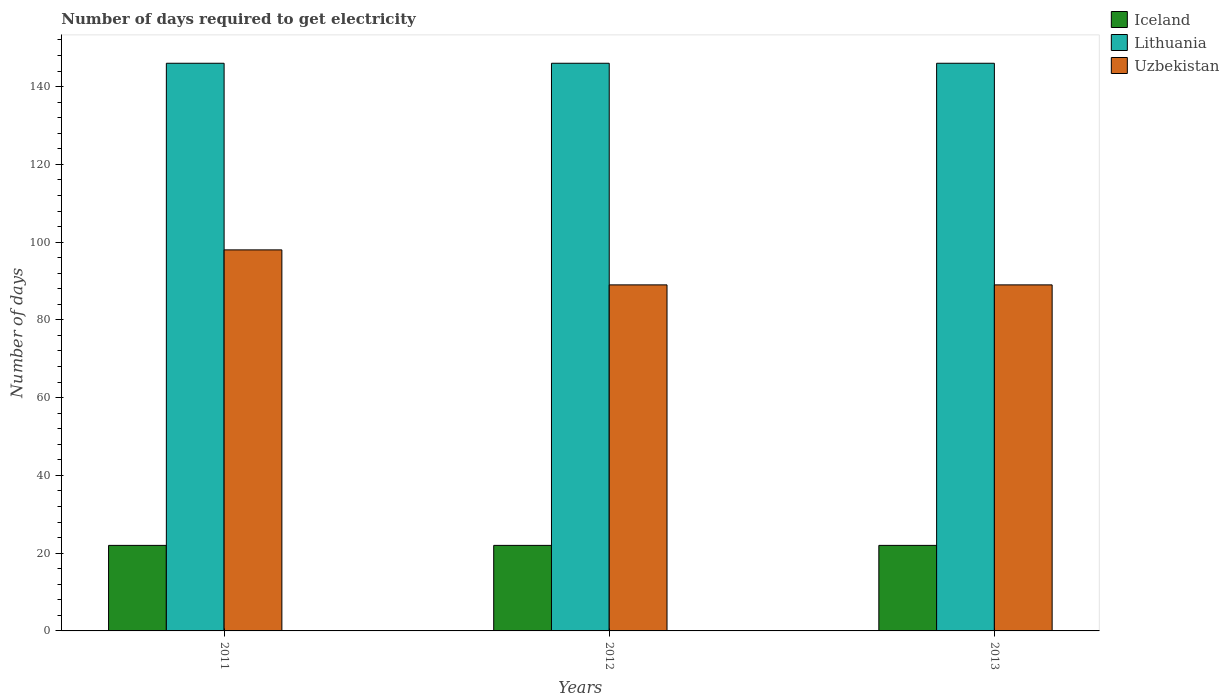How many bars are there on the 3rd tick from the right?
Your answer should be very brief. 3. What is the label of the 1st group of bars from the left?
Your answer should be compact. 2011. What is the number of days required to get electricity in in Iceland in 2013?
Make the answer very short. 22. Across all years, what is the maximum number of days required to get electricity in in Lithuania?
Offer a terse response. 146. Across all years, what is the minimum number of days required to get electricity in in Lithuania?
Offer a very short reply. 146. In which year was the number of days required to get electricity in in Lithuania maximum?
Your answer should be very brief. 2011. What is the total number of days required to get electricity in in Lithuania in the graph?
Offer a terse response. 438. What is the difference between the number of days required to get electricity in in Lithuania in 2011 and that in 2013?
Make the answer very short. 0. What is the difference between the number of days required to get electricity in in Lithuania in 2011 and the number of days required to get electricity in in Iceland in 2012?
Provide a short and direct response. 124. What is the average number of days required to get electricity in in Uzbekistan per year?
Offer a terse response. 92. In the year 2011, what is the difference between the number of days required to get electricity in in Iceland and number of days required to get electricity in in Lithuania?
Make the answer very short. -124. In how many years, is the number of days required to get electricity in in Lithuania greater than 104 days?
Make the answer very short. 3. What is the ratio of the number of days required to get electricity in in Uzbekistan in 2011 to that in 2012?
Provide a succinct answer. 1.1. What is the difference between the highest and the lowest number of days required to get electricity in in Uzbekistan?
Keep it short and to the point. 9. In how many years, is the number of days required to get electricity in in Uzbekistan greater than the average number of days required to get electricity in in Uzbekistan taken over all years?
Provide a short and direct response. 1. Is the sum of the number of days required to get electricity in in Uzbekistan in 2011 and 2013 greater than the maximum number of days required to get electricity in in Lithuania across all years?
Give a very brief answer. Yes. What does the 2nd bar from the left in 2011 represents?
Your answer should be very brief. Lithuania. What does the 1st bar from the right in 2012 represents?
Ensure brevity in your answer.  Uzbekistan. Is it the case that in every year, the sum of the number of days required to get electricity in in Iceland and number of days required to get electricity in in Lithuania is greater than the number of days required to get electricity in in Uzbekistan?
Make the answer very short. Yes. How many years are there in the graph?
Your response must be concise. 3. Where does the legend appear in the graph?
Offer a terse response. Top right. How many legend labels are there?
Offer a terse response. 3. How are the legend labels stacked?
Provide a succinct answer. Vertical. What is the title of the graph?
Offer a very short reply. Number of days required to get electricity. Does "Canada" appear as one of the legend labels in the graph?
Offer a terse response. No. What is the label or title of the Y-axis?
Offer a very short reply. Number of days. What is the Number of days in Lithuania in 2011?
Make the answer very short. 146. What is the Number of days in Uzbekistan in 2011?
Provide a short and direct response. 98. What is the Number of days of Iceland in 2012?
Ensure brevity in your answer.  22. What is the Number of days of Lithuania in 2012?
Provide a short and direct response. 146. What is the Number of days in Uzbekistan in 2012?
Your response must be concise. 89. What is the Number of days of Iceland in 2013?
Keep it short and to the point. 22. What is the Number of days of Lithuania in 2013?
Provide a short and direct response. 146. What is the Number of days of Uzbekistan in 2013?
Provide a succinct answer. 89. Across all years, what is the maximum Number of days of Iceland?
Offer a very short reply. 22. Across all years, what is the maximum Number of days in Lithuania?
Make the answer very short. 146. Across all years, what is the minimum Number of days of Iceland?
Provide a short and direct response. 22. Across all years, what is the minimum Number of days of Lithuania?
Offer a terse response. 146. Across all years, what is the minimum Number of days in Uzbekistan?
Ensure brevity in your answer.  89. What is the total Number of days of Lithuania in the graph?
Offer a terse response. 438. What is the total Number of days in Uzbekistan in the graph?
Make the answer very short. 276. What is the difference between the Number of days in Iceland in 2011 and that in 2012?
Offer a very short reply. 0. What is the difference between the Number of days in Lithuania in 2011 and that in 2012?
Your answer should be very brief. 0. What is the difference between the Number of days of Uzbekistan in 2011 and that in 2013?
Your answer should be very brief. 9. What is the difference between the Number of days in Iceland in 2012 and that in 2013?
Your response must be concise. 0. What is the difference between the Number of days of Lithuania in 2012 and that in 2013?
Ensure brevity in your answer.  0. What is the difference between the Number of days of Iceland in 2011 and the Number of days of Lithuania in 2012?
Provide a succinct answer. -124. What is the difference between the Number of days of Iceland in 2011 and the Number of days of Uzbekistan in 2012?
Make the answer very short. -67. What is the difference between the Number of days in Iceland in 2011 and the Number of days in Lithuania in 2013?
Your response must be concise. -124. What is the difference between the Number of days of Iceland in 2011 and the Number of days of Uzbekistan in 2013?
Your response must be concise. -67. What is the difference between the Number of days of Iceland in 2012 and the Number of days of Lithuania in 2013?
Offer a very short reply. -124. What is the difference between the Number of days of Iceland in 2012 and the Number of days of Uzbekistan in 2013?
Your response must be concise. -67. What is the average Number of days in Iceland per year?
Give a very brief answer. 22. What is the average Number of days of Lithuania per year?
Make the answer very short. 146. What is the average Number of days of Uzbekistan per year?
Your answer should be compact. 92. In the year 2011, what is the difference between the Number of days in Iceland and Number of days in Lithuania?
Ensure brevity in your answer.  -124. In the year 2011, what is the difference between the Number of days in Iceland and Number of days in Uzbekistan?
Your answer should be compact. -76. In the year 2011, what is the difference between the Number of days in Lithuania and Number of days in Uzbekistan?
Offer a very short reply. 48. In the year 2012, what is the difference between the Number of days of Iceland and Number of days of Lithuania?
Your answer should be very brief. -124. In the year 2012, what is the difference between the Number of days in Iceland and Number of days in Uzbekistan?
Provide a succinct answer. -67. In the year 2013, what is the difference between the Number of days in Iceland and Number of days in Lithuania?
Provide a short and direct response. -124. In the year 2013, what is the difference between the Number of days of Iceland and Number of days of Uzbekistan?
Provide a short and direct response. -67. In the year 2013, what is the difference between the Number of days of Lithuania and Number of days of Uzbekistan?
Make the answer very short. 57. What is the ratio of the Number of days of Iceland in 2011 to that in 2012?
Offer a very short reply. 1. What is the ratio of the Number of days of Uzbekistan in 2011 to that in 2012?
Offer a terse response. 1.1. What is the ratio of the Number of days in Iceland in 2011 to that in 2013?
Keep it short and to the point. 1. What is the ratio of the Number of days of Lithuania in 2011 to that in 2013?
Offer a very short reply. 1. What is the ratio of the Number of days in Uzbekistan in 2011 to that in 2013?
Offer a very short reply. 1.1. What is the ratio of the Number of days in Uzbekistan in 2012 to that in 2013?
Give a very brief answer. 1. What is the difference between the highest and the lowest Number of days in Lithuania?
Keep it short and to the point. 0. What is the difference between the highest and the lowest Number of days in Uzbekistan?
Keep it short and to the point. 9. 